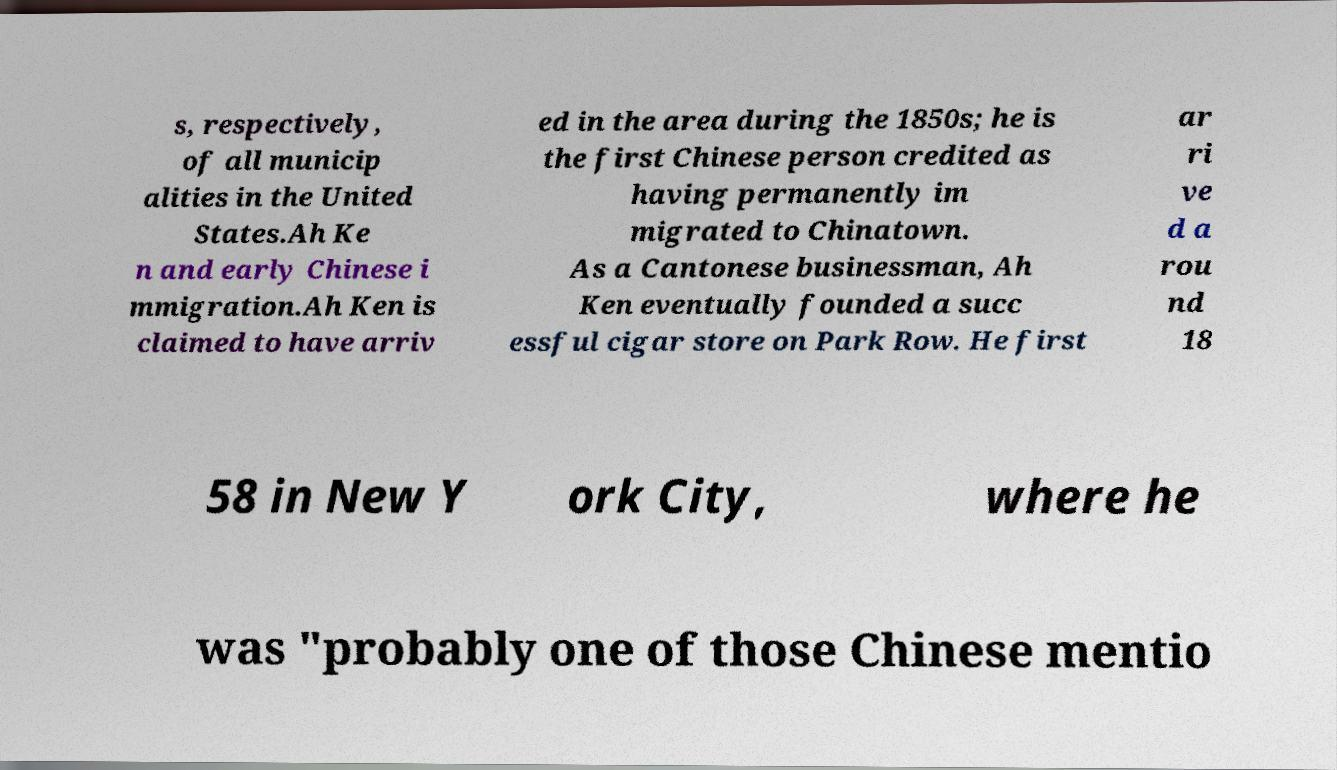I need the written content from this picture converted into text. Can you do that? s, respectively, of all municip alities in the United States.Ah Ke n and early Chinese i mmigration.Ah Ken is claimed to have arriv ed in the area during the 1850s; he is the first Chinese person credited as having permanently im migrated to Chinatown. As a Cantonese businessman, Ah Ken eventually founded a succ essful cigar store on Park Row. He first ar ri ve d a rou nd 18 58 in New Y ork City, where he was "probably one of those Chinese mentio 